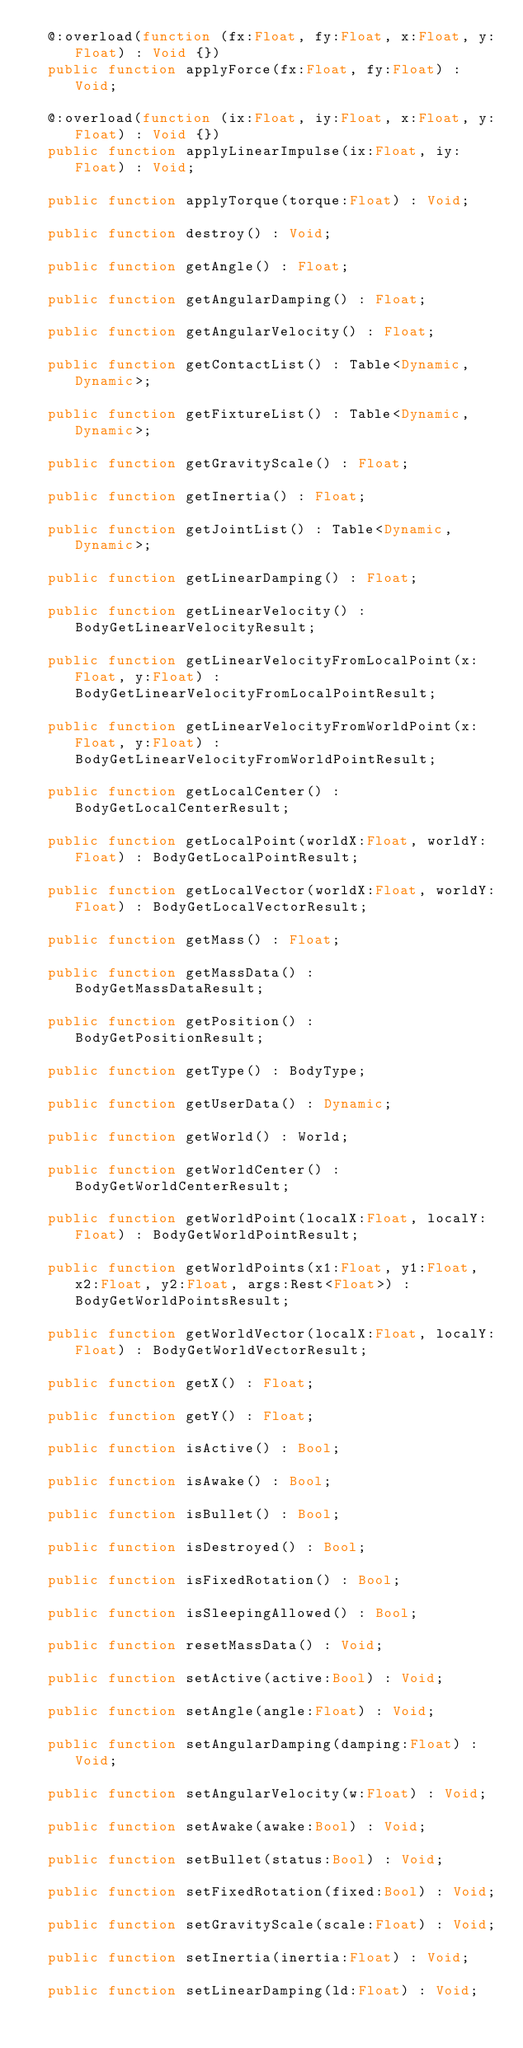Convert code to text. <code><loc_0><loc_0><loc_500><loc_500><_Haxe_>	@:overload(function (fx:Float, fy:Float, x:Float, y:Float) : Void {})
	public function applyForce(fx:Float, fy:Float) : Void;

	@:overload(function (ix:Float, iy:Float, x:Float, y:Float) : Void {})
	public function applyLinearImpulse(ix:Float, iy:Float) : Void;

	public function applyTorque(torque:Float) : Void;

	public function destroy() : Void;

	public function getAngle() : Float;

	public function getAngularDamping() : Float;

	public function getAngularVelocity() : Float;

	public function getContactList() : Table<Dynamic,Dynamic>;

	public function getFixtureList() : Table<Dynamic,Dynamic>;

	public function getGravityScale() : Float;

	public function getInertia() : Float;

	public function getJointList() : Table<Dynamic,Dynamic>;

	public function getLinearDamping() : Float;

	public function getLinearVelocity() : BodyGetLinearVelocityResult;

	public function getLinearVelocityFromLocalPoint(x:Float, y:Float) : BodyGetLinearVelocityFromLocalPointResult;

	public function getLinearVelocityFromWorldPoint(x:Float, y:Float) : BodyGetLinearVelocityFromWorldPointResult;

	public function getLocalCenter() : BodyGetLocalCenterResult;

	public function getLocalPoint(worldX:Float, worldY:Float) : BodyGetLocalPointResult;

	public function getLocalVector(worldX:Float, worldY:Float) : BodyGetLocalVectorResult;

	public function getMass() : Float;

	public function getMassData() : BodyGetMassDataResult;

	public function getPosition() : BodyGetPositionResult;

	public function getType() : BodyType;

	public function getUserData() : Dynamic;

	public function getWorld() : World;

	public function getWorldCenter() : BodyGetWorldCenterResult;

	public function getWorldPoint(localX:Float, localY:Float) : BodyGetWorldPointResult;

	public function getWorldPoints(x1:Float, y1:Float, x2:Float, y2:Float, args:Rest<Float>) : BodyGetWorldPointsResult;

	public function getWorldVector(localX:Float, localY:Float) : BodyGetWorldVectorResult;

	public function getX() : Float;

	public function getY() : Float;

	public function isActive() : Bool;

	public function isAwake() : Bool;

	public function isBullet() : Bool;

	public function isDestroyed() : Bool;

	public function isFixedRotation() : Bool;

	public function isSleepingAllowed() : Bool;

	public function resetMassData() : Void;

	public function setActive(active:Bool) : Void;

	public function setAngle(angle:Float) : Void;

	public function setAngularDamping(damping:Float) : Void;

	public function setAngularVelocity(w:Float) : Void;

	public function setAwake(awake:Bool) : Void;

	public function setBullet(status:Bool) : Void;

	public function setFixedRotation(fixed:Bool) : Void;

	public function setGravityScale(scale:Float) : Void;

	public function setInertia(inertia:Float) : Void;

	public function setLinearDamping(ld:Float) : Void;
</code> 